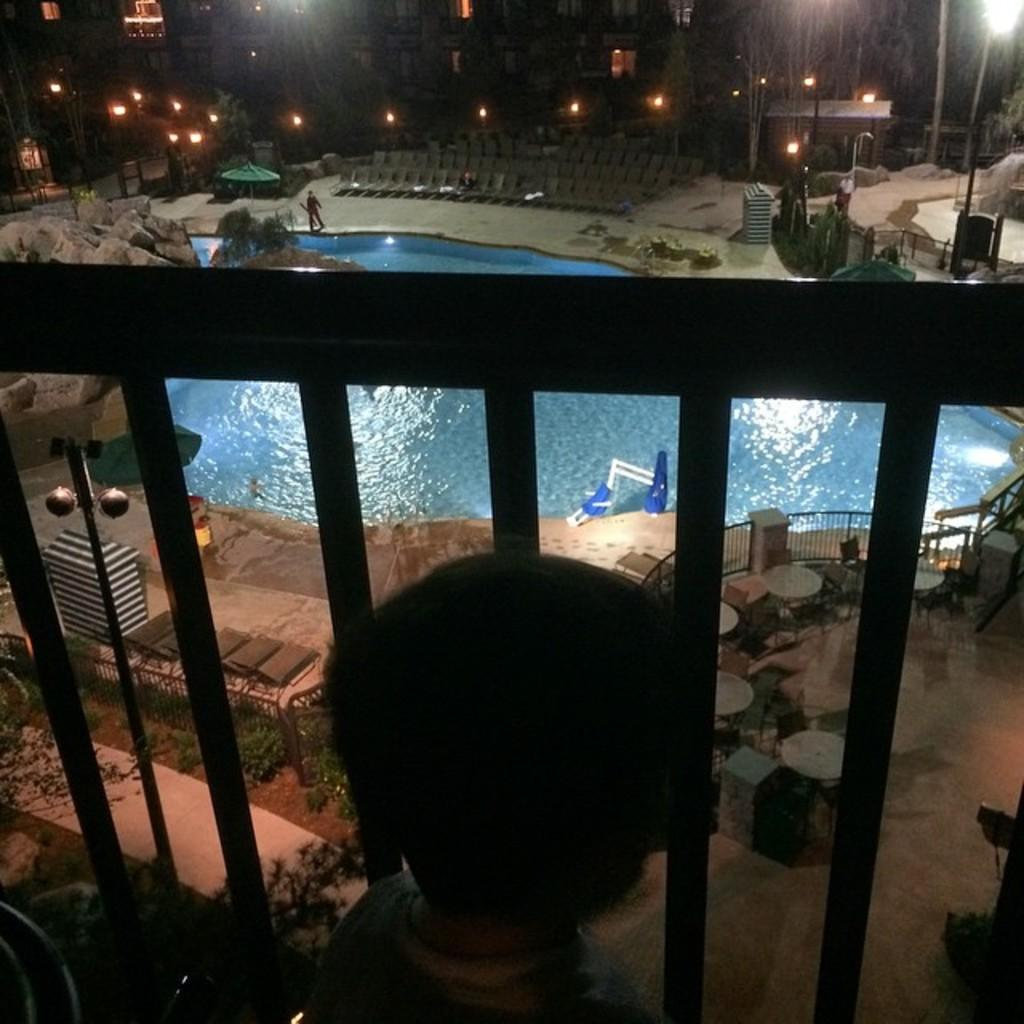What type of recreational facility can be seen in the image? There is a swimming pool present in the image. What safety feature is in place in the swimming pool area? There is a safety barrier in the middle of the image. What type of urban infrastructure can be seen at the top of the image? Street poles are visible at the top of the image. What type of powder is being used to season the fork in the image? There is no fork or powder present in the image. 